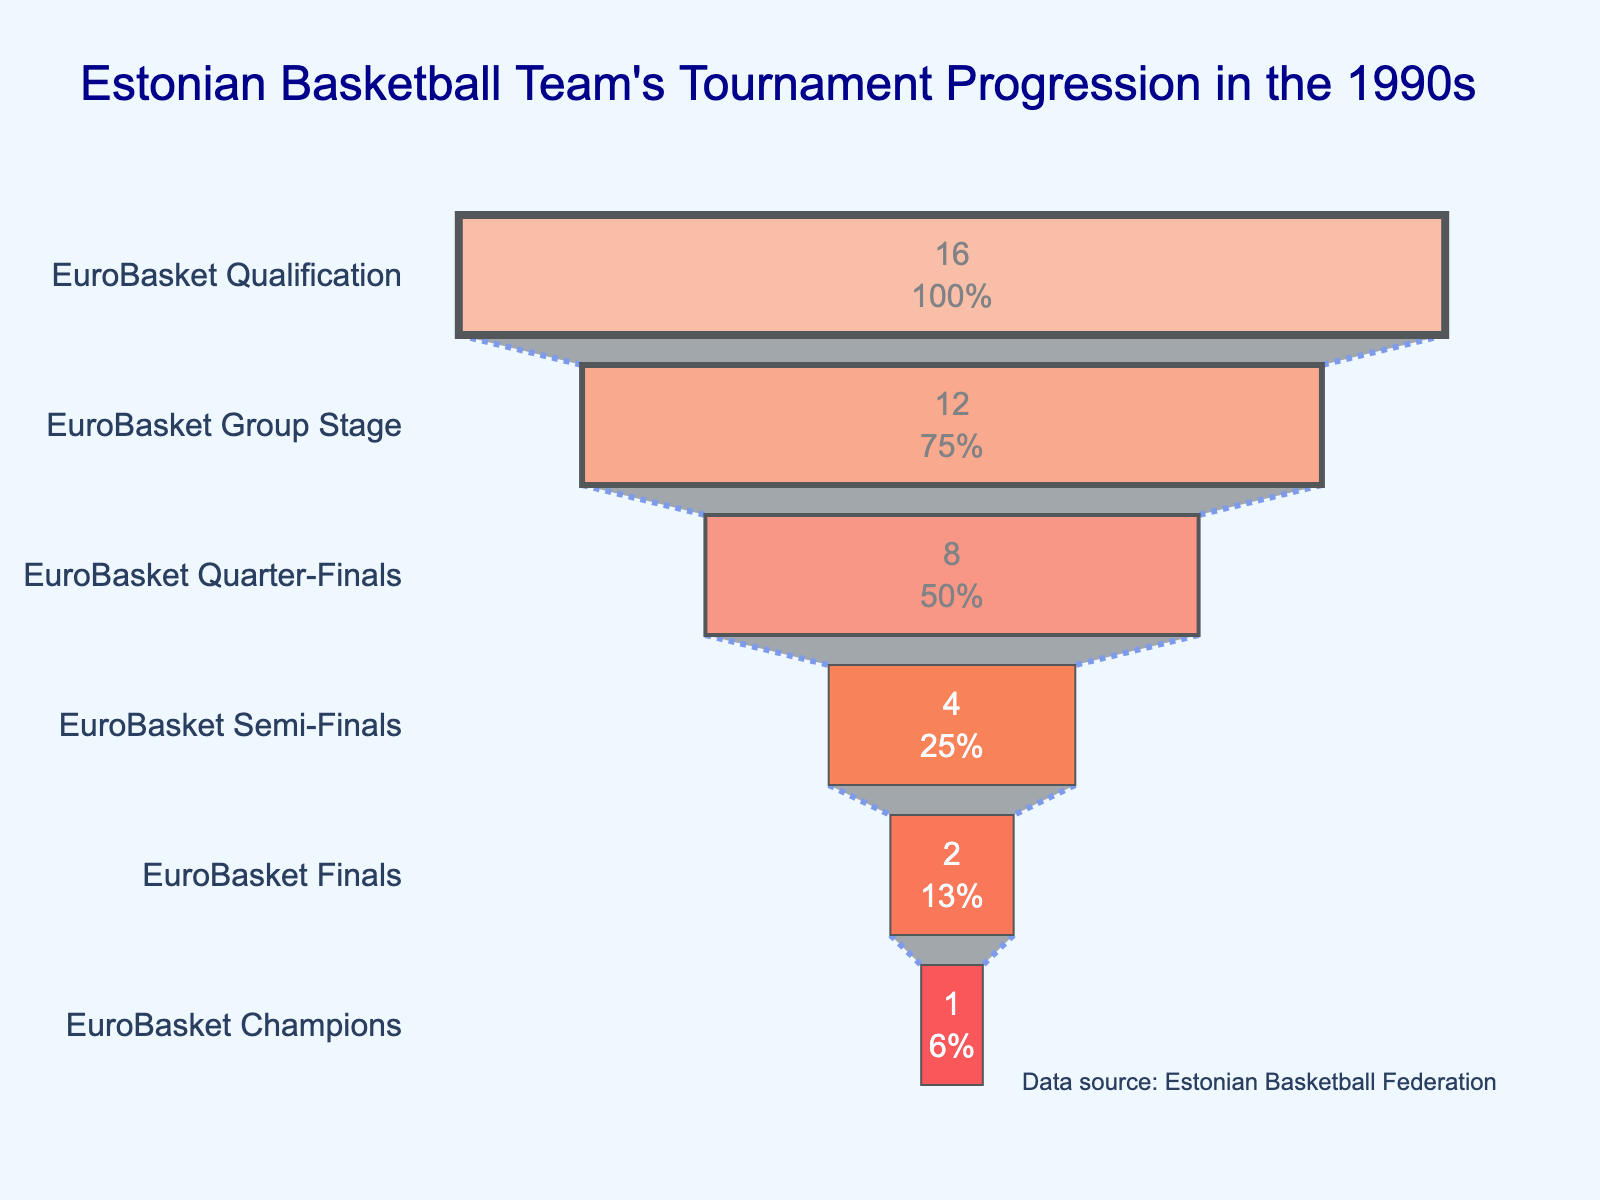What is the title of the chart? The title is located at the top of the chart. It reads, "Estonian Basketball Team's Tournament Progression in the 1990s."
Answer: Estonian Basketball Team's Tournament Progression in the 1990s How many teams started in the EuroBasket Qualification stage? The chart shows "EuroBasket Qualification" at the top of the funnel with 16 teams qualified.
Answer: 16 What percentage of teams made it to the EuroBasket Group Stage? The text inside the "EuroBasket Group Stage" part of the funnel usually contains this information. It is "12" teams out of "16". Calculate 12/16 and convert to a percentage.
Answer: 75% At which stage did the number of teams halve for the first time? To answer this, you need to examine the reduction in the number of teams between stages. The first halving occurs from "Quarter-Finals" (8 teams) to "Semi-Finals" (4 teams).
Answer: Quarter-Finals to Semi-Finals How many teams advanced to the EuroBasket Finals? The "EuroBasket Finals" part of the funnel shows the number "2."
Answer: 2 By what factor did the number of teams decrease from the Semi-Finals to the Champions? The "Semi-Finals" had 4 teams, and the "Champions" had 1 team. The decrease factor is 4 divided by 1.
Answer: 4 What is the color of the stage where the Estonian team would have been EuroBasket Champions? The colors are visible in the funnel chart. The "EuroBasket Champions" stage is colored red.
Answer: Red How many stages are there in total for the Estonian basketball team's progression? The funnel chart has labeled stages. Counting them from "EuroBasket Qualification" to "EuroBasket Champions," there are six stages.
Answer: 6 Which stage had the most significant drop in teams qualified? Compare the drops between successive stages by subtracting the number of qualified teams at each stage. The largest drop-from "EuroBasket Qualification" (16 teams) to "EuroBasket Group Stage" (12 teams) is by 4.
Answer: EuroBasket Qualification to Group Stage What percentage of the initial teams reached the final? The initial number of teams is 16 from the "EuroBasket Qualification". The final stage had 2 teams. The percentage is (2/16) * 100.
Answer: 12.5% 